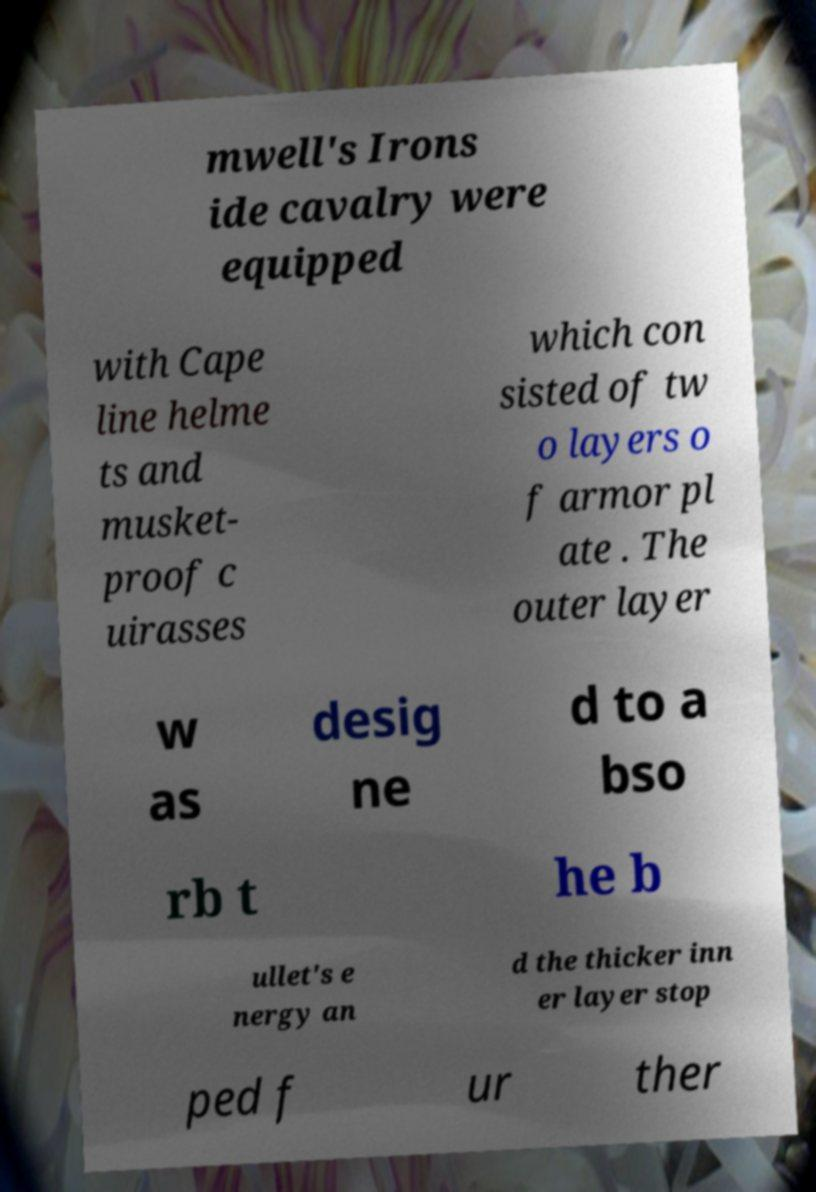For documentation purposes, I need the text within this image transcribed. Could you provide that? mwell's Irons ide cavalry were equipped with Cape line helme ts and musket- proof c uirasses which con sisted of tw o layers o f armor pl ate . The outer layer w as desig ne d to a bso rb t he b ullet's e nergy an d the thicker inn er layer stop ped f ur ther 